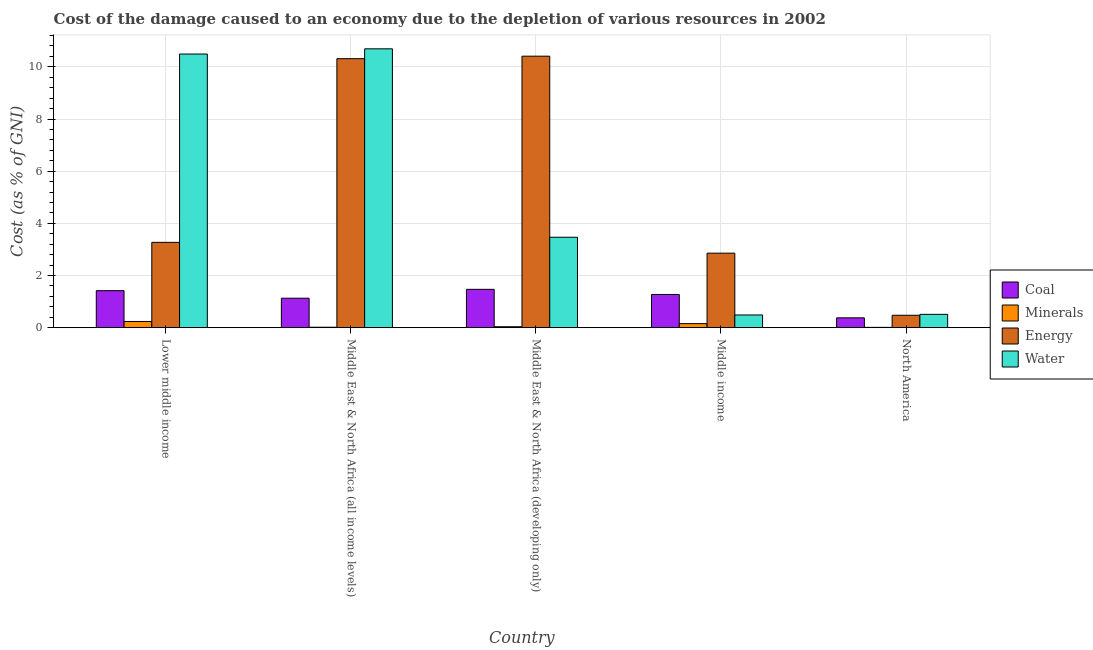How many groups of bars are there?
Your answer should be compact. 5. Are the number of bars per tick equal to the number of legend labels?
Your answer should be compact. Yes. How many bars are there on the 1st tick from the right?
Offer a terse response. 4. In how many cases, is the number of bars for a given country not equal to the number of legend labels?
Your response must be concise. 0. What is the cost of damage due to depletion of coal in North America?
Your response must be concise. 0.38. Across all countries, what is the maximum cost of damage due to depletion of water?
Give a very brief answer. 10.69. Across all countries, what is the minimum cost of damage due to depletion of coal?
Make the answer very short. 0.38. In which country was the cost of damage due to depletion of minerals maximum?
Offer a terse response. Lower middle income. What is the total cost of damage due to depletion of coal in the graph?
Ensure brevity in your answer.  5.67. What is the difference between the cost of damage due to depletion of minerals in Lower middle income and that in Middle East & North Africa (all income levels)?
Your answer should be very brief. 0.22. What is the difference between the cost of damage due to depletion of energy in Middle income and the cost of damage due to depletion of coal in Middle East & North Africa (all income levels)?
Your answer should be very brief. 1.73. What is the average cost of damage due to depletion of minerals per country?
Your response must be concise. 0.09. What is the difference between the cost of damage due to depletion of water and cost of damage due to depletion of minerals in Lower middle income?
Offer a terse response. 10.25. In how many countries, is the cost of damage due to depletion of water greater than 2.4 %?
Provide a succinct answer. 3. What is the ratio of the cost of damage due to depletion of energy in Lower middle income to that in Middle East & North Africa (developing only)?
Provide a short and direct response. 0.31. Is the cost of damage due to depletion of energy in Lower middle income less than that in Middle East & North Africa (all income levels)?
Ensure brevity in your answer.  Yes. What is the difference between the highest and the second highest cost of damage due to depletion of coal?
Your response must be concise. 0.05. What is the difference between the highest and the lowest cost of damage due to depletion of minerals?
Keep it short and to the point. 0.23. Is it the case that in every country, the sum of the cost of damage due to depletion of minerals and cost of damage due to depletion of coal is greater than the sum of cost of damage due to depletion of water and cost of damage due to depletion of energy?
Keep it short and to the point. Yes. What does the 2nd bar from the left in Middle income represents?
Offer a very short reply. Minerals. What does the 1st bar from the right in Lower middle income represents?
Provide a succinct answer. Water. Is it the case that in every country, the sum of the cost of damage due to depletion of coal and cost of damage due to depletion of minerals is greater than the cost of damage due to depletion of energy?
Keep it short and to the point. No. How many bars are there?
Provide a short and direct response. 20. How many countries are there in the graph?
Make the answer very short. 5. What is the difference between two consecutive major ticks on the Y-axis?
Your response must be concise. 2. Are the values on the major ticks of Y-axis written in scientific E-notation?
Your answer should be very brief. No. Does the graph contain grids?
Make the answer very short. Yes. How many legend labels are there?
Keep it short and to the point. 4. How are the legend labels stacked?
Your answer should be very brief. Vertical. What is the title of the graph?
Keep it short and to the point. Cost of the damage caused to an economy due to the depletion of various resources in 2002 . Does "Oil" appear as one of the legend labels in the graph?
Give a very brief answer. No. What is the label or title of the X-axis?
Ensure brevity in your answer.  Country. What is the label or title of the Y-axis?
Give a very brief answer. Cost (as % of GNI). What is the Cost (as % of GNI) of Coal in Lower middle income?
Keep it short and to the point. 1.42. What is the Cost (as % of GNI) in Minerals in Lower middle income?
Your response must be concise. 0.24. What is the Cost (as % of GNI) in Energy in Lower middle income?
Ensure brevity in your answer.  3.27. What is the Cost (as % of GNI) of Water in Lower middle income?
Your answer should be compact. 10.49. What is the Cost (as % of GNI) in Coal in Middle East & North Africa (all income levels)?
Your answer should be very brief. 1.13. What is the Cost (as % of GNI) of Minerals in Middle East & North Africa (all income levels)?
Your response must be concise. 0.02. What is the Cost (as % of GNI) of Energy in Middle East & North Africa (all income levels)?
Offer a terse response. 10.31. What is the Cost (as % of GNI) of Water in Middle East & North Africa (all income levels)?
Your answer should be very brief. 10.69. What is the Cost (as % of GNI) in Coal in Middle East & North Africa (developing only)?
Your answer should be very brief. 1.47. What is the Cost (as % of GNI) of Minerals in Middle East & North Africa (developing only)?
Your response must be concise. 0.04. What is the Cost (as % of GNI) in Energy in Middle East & North Africa (developing only)?
Make the answer very short. 10.41. What is the Cost (as % of GNI) in Water in Middle East & North Africa (developing only)?
Make the answer very short. 3.47. What is the Cost (as % of GNI) in Coal in Middle income?
Ensure brevity in your answer.  1.27. What is the Cost (as % of GNI) of Minerals in Middle income?
Provide a succinct answer. 0.16. What is the Cost (as % of GNI) in Energy in Middle income?
Make the answer very short. 2.86. What is the Cost (as % of GNI) of Water in Middle income?
Your answer should be very brief. 0.49. What is the Cost (as % of GNI) of Coal in North America?
Give a very brief answer. 0.38. What is the Cost (as % of GNI) of Minerals in North America?
Your answer should be very brief. 0.01. What is the Cost (as % of GNI) of Energy in North America?
Your answer should be very brief. 0.48. What is the Cost (as % of GNI) of Water in North America?
Your response must be concise. 0.51. Across all countries, what is the maximum Cost (as % of GNI) in Coal?
Make the answer very short. 1.47. Across all countries, what is the maximum Cost (as % of GNI) of Minerals?
Offer a very short reply. 0.24. Across all countries, what is the maximum Cost (as % of GNI) of Energy?
Offer a terse response. 10.41. Across all countries, what is the maximum Cost (as % of GNI) in Water?
Provide a short and direct response. 10.69. Across all countries, what is the minimum Cost (as % of GNI) in Coal?
Ensure brevity in your answer.  0.38. Across all countries, what is the minimum Cost (as % of GNI) in Minerals?
Offer a very short reply. 0.01. Across all countries, what is the minimum Cost (as % of GNI) of Energy?
Provide a succinct answer. 0.48. Across all countries, what is the minimum Cost (as % of GNI) of Water?
Make the answer very short. 0.49. What is the total Cost (as % of GNI) of Coal in the graph?
Ensure brevity in your answer.  5.67. What is the total Cost (as % of GNI) of Minerals in the graph?
Your answer should be compact. 0.46. What is the total Cost (as % of GNI) of Energy in the graph?
Ensure brevity in your answer.  27.33. What is the total Cost (as % of GNI) in Water in the graph?
Provide a succinct answer. 25.65. What is the difference between the Cost (as % of GNI) of Coal in Lower middle income and that in Middle East & North Africa (all income levels)?
Provide a short and direct response. 0.29. What is the difference between the Cost (as % of GNI) in Minerals in Lower middle income and that in Middle East & North Africa (all income levels)?
Offer a very short reply. 0.22. What is the difference between the Cost (as % of GNI) of Energy in Lower middle income and that in Middle East & North Africa (all income levels)?
Ensure brevity in your answer.  -7.04. What is the difference between the Cost (as % of GNI) in Water in Lower middle income and that in Middle East & North Africa (all income levels)?
Your answer should be very brief. -0.2. What is the difference between the Cost (as % of GNI) of Coal in Lower middle income and that in Middle East & North Africa (developing only)?
Ensure brevity in your answer.  -0.05. What is the difference between the Cost (as % of GNI) in Minerals in Lower middle income and that in Middle East & North Africa (developing only)?
Make the answer very short. 0.2. What is the difference between the Cost (as % of GNI) in Energy in Lower middle income and that in Middle East & North Africa (developing only)?
Your answer should be compact. -7.14. What is the difference between the Cost (as % of GNI) of Water in Lower middle income and that in Middle East & North Africa (developing only)?
Offer a very short reply. 7.02. What is the difference between the Cost (as % of GNI) in Coal in Lower middle income and that in Middle income?
Provide a short and direct response. 0.15. What is the difference between the Cost (as % of GNI) in Minerals in Lower middle income and that in Middle income?
Your answer should be very brief. 0.08. What is the difference between the Cost (as % of GNI) in Energy in Lower middle income and that in Middle income?
Make the answer very short. 0.41. What is the difference between the Cost (as % of GNI) of Water in Lower middle income and that in Middle income?
Your response must be concise. 10.01. What is the difference between the Cost (as % of GNI) in Coal in Lower middle income and that in North America?
Your answer should be compact. 1.04. What is the difference between the Cost (as % of GNI) in Minerals in Lower middle income and that in North America?
Provide a short and direct response. 0.23. What is the difference between the Cost (as % of GNI) in Energy in Lower middle income and that in North America?
Your answer should be very brief. 2.8. What is the difference between the Cost (as % of GNI) of Water in Lower middle income and that in North America?
Ensure brevity in your answer.  9.98. What is the difference between the Cost (as % of GNI) in Coal in Middle East & North Africa (all income levels) and that in Middle East & North Africa (developing only)?
Offer a very short reply. -0.34. What is the difference between the Cost (as % of GNI) in Minerals in Middle East & North Africa (all income levels) and that in Middle East & North Africa (developing only)?
Make the answer very short. -0.02. What is the difference between the Cost (as % of GNI) in Energy in Middle East & North Africa (all income levels) and that in Middle East & North Africa (developing only)?
Offer a very short reply. -0.1. What is the difference between the Cost (as % of GNI) of Water in Middle East & North Africa (all income levels) and that in Middle East & North Africa (developing only)?
Ensure brevity in your answer.  7.22. What is the difference between the Cost (as % of GNI) of Coal in Middle East & North Africa (all income levels) and that in Middle income?
Give a very brief answer. -0.14. What is the difference between the Cost (as % of GNI) in Minerals in Middle East & North Africa (all income levels) and that in Middle income?
Keep it short and to the point. -0.14. What is the difference between the Cost (as % of GNI) in Energy in Middle East & North Africa (all income levels) and that in Middle income?
Your answer should be very brief. 7.46. What is the difference between the Cost (as % of GNI) of Water in Middle East & North Africa (all income levels) and that in Middle income?
Make the answer very short. 10.2. What is the difference between the Cost (as % of GNI) in Coal in Middle East & North Africa (all income levels) and that in North America?
Make the answer very short. 0.75. What is the difference between the Cost (as % of GNI) of Minerals in Middle East & North Africa (all income levels) and that in North America?
Offer a very short reply. 0.01. What is the difference between the Cost (as % of GNI) in Energy in Middle East & North Africa (all income levels) and that in North America?
Keep it short and to the point. 9.84. What is the difference between the Cost (as % of GNI) in Water in Middle East & North Africa (all income levels) and that in North America?
Make the answer very short. 10.18. What is the difference between the Cost (as % of GNI) in Coal in Middle East & North Africa (developing only) and that in Middle income?
Your response must be concise. 0.2. What is the difference between the Cost (as % of GNI) in Minerals in Middle East & North Africa (developing only) and that in Middle income?
Offer a very short reply. -0.12. What is the difference between the Cost (as % of GNI) in Energy in Middle East & North Africa (developing only) and that in Middle income?
Ensure brevity in your answer.  7.55. What is the difference between the Cost (as % of GNI) in Water in Middle East & North Africa (developing only) and that in Middle income?
Offer a terse response. 2.98. What is the difference between the Cost (as % of GNI) of Coal in Middle East & North Africa (developing only) and that in North America?
Keep it short and to the point. 1.09. What is the difference between the Cost (as % of GNI) in Minerals in Middle East & North Africa (developing only) and that in North America?
Offer a very short reply. 0.02. What is the difference between the Cost (as % of GNI) in Energy in Middle East & North Africa (developing only) and that in North America?
Give a very brief answer. 9.93. What is the difference between the Cost (as % of GNI) of Water in Middle East & North Africa (developing only) and that in North America?
Keep it short and to the point. 2.96. What is the difference between the Cost (as % of GNI) in Coal in Middle income and that in North America?
Your answer should be compact. 0.9. What is the difference between the Cost (as % of GNI) in Minerals in Middle income and that in North America?
Your answer should be compact. 0.14. What is the difference between the Cost (as % of GNI) in Energy in Middle income and that in North America?
Ensure brevity in your answer.  2.38. What is the difference between the Cost (as % of GNI) in Water in Middle income and that in North America?
Provide a succinct answer. -0.02. What is the difference between the Cost (as % of GNI) of Coal in Lower middle income and the Cost (as % of GNI) of Minerals in Middle East & North Africa (all income levels)?
Ensure brevity in your answer.  1.4. What is the difference between the Cost (as % of GNI) of Coal in Lower middle income and the Cost (as % of GNI) of Energy in Middle East & North Africa (all income levels)?
Provide a succinct answer. -8.89. What is the difference between the Cost (as % of GNI) of Coal in Lower middle income and the Cost (as % of GNI) of Water in Middle East & North Africa (all income levels)?
Offer a terse response. -9.27. What is the difference between the Cost (as % of GNI) of Minerals in Lower middle income and the Cost (as % of GNI) of Energy in Middle East & North Africa (all income levels)?
Keep it short and to the point. -10.08. What is the difference between the Cost (as % of GNI) in Minerals in Lower middle income and the Cost (as % of GNI) in Water in Middle East & North Africa (all income levels)?
Give a very brief answer. -10.45. What is the difference between the Cost (as % of GNI) of Energy in Lower middle income and the Cost (as % of GNI) of Water in Middle East & North Africa (all income levels)?
Ensure brevity in your answer.  -7.42. What is the difference between the Cost (as % of GNI) of Coal in Lower middle income and the Cost (as % of GNI) of Minerals in Middle East & North Africa (developing only)?
Provide a short and direct response. 1.38. What is the difference between the Cost (as % of GNI) of Coal in Lower middle income and the Cost (as % of GNI) of Energy in Middle East & North Africa (developing only)?
Offer a terse response. -8.99. What is the difference between the Cost (as % of GNI) in Coal in Lower middle income and the Cost (as % of GNI) in Water in Middle East & North Africa (developing only)?
Give a very brief answer. -2.05. What is the difference between the Cost (as % of GNI) in Minerals in Lower middle income and the Cost (as % of GNI) in Energy in Middle East & North Africa (developing only)?
Give a very brief answer. -10.17. What is the difference between the Cost (as % of GNI) of Minerals in Lower middle income and the Cost (as % of GNI) of Water in Middle East & North Africa (developing only)?
Keep it short and to the point. -3.23. What is the difference between the Cost (as % of GNI) of Energy in Lower middle income and the Cost (as % of GNI) of Water in Middle East & North Africa (developing only)?
Give a very brief answer. -0.2. What is the difference between the Cost (as % of GNI) in Coal in Lower middle income and the Cost (as % of GNI) in Minerals in Middle income?
Offer a very short reply. 1.26. What is the difference between the Cost (as % of GNI) in Coal in Lower middle income and the Cost (as % of GNI) in Energy in Middle income?
Offer a terse response. -1.44. What is the difference between the Cost (as % of GNI) in Coal in Lower middle income and the Cost (as % of GNI) in Water in Middle income?
Make the answer very short. 0.93. What is the difference between the Cost (as % of GNI) in Minerals in Lower middle income and the Cost (as % of GNI) in Energy in Middle income?
Offer a very short reply. -2.62. What is the difference between the Cost (as % of GNI) of Minerals in Lower middle income and the Cost (as % of GNI) of Water in Middle income?
Make the answer very short. -0.25. What is the difference between the Cost (as % of GNI) of Energy in Lower middle income and the Cost (as % of GNI) of Water in Middle income?
Provide a short and direct response. 2.78. What is the difference between the Cost (as % of GNI) of Coal in Lower middle income and the Cost (as % of GNI) of Minerals in North America?
Offer a terse response. 1.41. What is the difference between the Cost (as % of GNI) in Coal in Lower middle income and the Cost (as % of GNI) in Energy in North America?
Your answer should be compact. 0.94. What is the difference between the Cost (as % of GNI) of Coal in Lower middle income and the Cost (as % of GNI) of Water in North America?
Your answer should be compact. 0.91. What is the difference between the Cost (as % of GNI) of Minerals in Lower middle income and the Cost (as % of GNI) of Energy in North America?
Provide a short and direct response. -0.24. What is the difference between the Cost (as % of GNI) in Minerals in Lower middle income and the Cost (as % of GNI) in Water in North America?
Provide a short and direct response. -0.27. What is the difference between the Cost (as % of GNI) of Energy in Lower middle income and the Cost (as % of GNI) of Water in North America?
Your response must be concise. 2.76. What is the difference between the Cost (as % of GNI) of Coal in Middle East & North Africa (all income levels) and the Cost (as % of GNI) of Minerals in Middle East & North Africa (developing only)?
Your response must be concise. 1.09. What is the difference between the Cost (as % of GNI) of Coal in Middle East & North Africa (all income levels) and the Cost (as % of GNI) of Energy in Middle East & North Africa (developing only)?
Your answer should be compact. -9.28. What is the difference between the Cost (as % of GNI) of Coal in Middle East & North Africa (all income levels) and the Cost (as % of GNI) of Water in Middle East & North Africa (developing only)?
Keep it short and to the point. -2.34. What is the difference between the Cost (as % of GNI) in Minerals in Middle East & North Africa (all income levels) and the Cost (as % of GNI) in Energy in Middle East & North Africa (developing only)?
Make the answer very short. -10.39. What is the difference between the Cost (as % of GNI) in Minerals in Middle East & North Africa (all income levels) and the Cost (as % of GNI) in Water in Middle East & North Africa (developing only)?
Provide a succinct answer. -3.45. What is the difference between the Cost (as % of GNI) in Energy in Middle East & North Africa (all income levels) and the Cost (as % of GNI) in Water in Middle East & North Africa (developing only)?
Ensure brevity in your answer.  6.85. What is the difference between the Cost (as % of GNI) of Coal in Middle East & North Africa (all income levels) and the Cost (as % of GNI) of Minerals in Middle income?
Offer a very short reply. 0.97. What is the difference between the Cost (as % of GNI) of Coal in Middle East & North Africa (all income levels) and the Cost (as % of GNI) of Energy in Middle income?
Make the answer very short. -1.73. What is the difference between the Cost (as % of GNI) in Coal in Middle East & North Africa (all income levels) and the Cost (as % of GNI) in Water in Middle income?
Offer a very short reply. 0.64. What is the difference between the Cost (as % of GNI) in Minerals in Middle East & North Africa (all income levels) and the Cost (as % of GNI) in Energy in Middle income?
Your answer should be compact. -2.84. What is the difference between the Cost (as % of GNI) in Minerals in Middle East & North Africa (all income levels) and the Cost (as % of GNI) in Water in Middle income?
Your answer should be very brief. -0.47. What is the difference between the Cost (as % of GNI) in Energy in Middle East & North Africa (all income levels) and the Cost (as % of GNI) in Water in Middle income?
Make the answer very short. 9.83. What is the difference between the Cost (as % of GNI) in Coal in Middle East & North Africa (all income levels) and the Cost (as % of GNI) in Minerals in North America?
Your answer should be compact. 1.12. What is the difference between the Cost (as % of GNI) of Coal in Middle East & North Africa (all income levels) and the Cost (as % of GNI) of Energy in North America?
Offer a terse response. 0.65. What is the difference between the Cost (as % of GNI) in Coal in Middle East & North Africa (all income levels) and the Cost (as % of GNI) in Water in North America?
Give a very brief answer. 0.62. What is the difference between the Cost (as % of GNI) in Minerals in Middle East & North Africa (all income levels) and the Cost (as % of GNI) in Energy in North America?
Offer a very short reply. -0.46. What is the difference between the Cost (as % of GNI) in Minerals in Middle East & North Africa (all income levels) and the Cost (as % of GNI) in Water in North America?
Provide a succinct answer. -0.49. What is the difference between the Cost (as % of GNI) of Energy in Middle East & North Africa (all income levels) and the Cost (as % of GNI) of Water in North America?
Keep it short and to the point. 9.8. What is the difference between the Cost (as % of GNI) of Coal in Middle East & North Africa (developing only) and the Cost (as % of GNI) of Minerals in Middle income?
Give a very brief answer. 1.31. What is the difference between the Cost (as % of GNI) of Coal in Middle East & North Africa (developing only) and the Cost (as % of GNI) of Energy in Middle income?
Your answer should be compact. -1.39. What is the difference between the Cost (as % of GNI) in Coal in Middle East & North Africa (developing only) and the Cost (as % of GNI) in Water in Middle income?
Ensure brevity in your answer.  0.98. What is the difference between the Cost (as % of GNI) in Minerals in Middle East & North Africa (developing only) and the Cost (as % of GNI) in Energy in Middle income?
Ensure brevity in your answer.  -2.82. What is the difference between the Cost (as % of GNI) in Minerals in Middle East & North Africa (developing only) and the Cost (as % of GNI) in Water in Middle income?
Keep it short and to the point. -0.45. What is the difference between the Cost (as % of GNI) of Energy in Middle East & North Africa (developing only) and the Cost (as % of GNI) of Water in Middle income?
Keep it short and to the point. 9.92. What is the difference between the Cost (as % of GNI) in Coal in Middle East & North Africa (developing only) and the Cost (as % of GNI) in Minerals in North America?
Ensure brevity in your answer.  1.46. What is the difference between the Cost (as % of GNI) of Coal in Middle East & North Africa (developing only) and the Cost (as % of GNI) of Energy in North America?
Your answer should be very brief. 0.99. What is the difference between the Cost (as % of GNI) of Coal in Middle East & North Africa (developing only) and the Cost (as % of GNI) of Water in North America?
Your response must be concise. 0.96. What is the difference between the Cost (as % of GNI) of Minerals in Middle East & North Africa (developing only) and the Cost (as % of GNI) of Energy in North America?
Your response must be concise. -0.44. What is the difference between the Cost (as % of GNI) in Minerals in Middle East & North Africa (developing only) and the Cost (as % of GNI) in Water in North America?
Your response must be concise. -0.47. What is the difference between the Cost (as % of GNI) of Energy in Middle East & North Africa (developing only) and the Cost (as % of GNI) of Water in North America?
Offer a very short reply. 9.9. What is the difference between the Cost (as % of GNI) of Coal in Middle income and the Cost (as % of GNI) of Minerals in North America?
Keep it short and to the point. 1.26. What is the difference between the Cost (as % of GNI) of Coal in Middle income and the Cost (as % of GNI) of Energy in North America?
Ensure brevity in your answer.  0.8. What is the difference between the Cost (as % of GNI) of Coal in Middle income and the Cost (as % of GNI) of Water in North America?
Your answer should be compact. 0.76. What is the difference between the Cost (as % of GNI) of Minerals in Middle income and the Cost (as % of GNI) of Energy in North America?
Your answer should be very brief. -0.32. What is the difference between the Cost (as % of GNI) of Minerals in Middle income and the Cost (as % of GNI) of Water in North America?
Give a very brief answer. -0.35. What is the difference between the Cost (as % of GNI) of Energy in Middle income and the Cost (as % of GNI) of Water in North America?
Provide a short and direct response. 2.35. What is the average Cost (as % of GNI) in Coal per country?
Provide a short and direct response. 1.13. What is the average Cost (as % of GNI) of Minerals per country?
Offer a very short reply. 0.09. What is the average Cost (as % of GNI) in Energy per country?
Your answer should be very brief. 5.47. What is the average Cost (as % of GNI) of Water per country?
Give a very brief answer. 5.13. What is the difference between the Cost (as % of GNI) of Coal and Cost (as % of GNI) of Minerals in Lower middle income?
Give a very brief answer. 1.18. What is the difference between the Cost (as % of GNI) in Coal and Cost (as % of GNI) in Energy in Lower middle income?
Your response must be concise. -1.85. What is the difference between the Cost (as % of GNI) of Coal and Cost (as % of GNI) of Water in Lower middle income?
Make the answer very short. -9.07. What is the difference between the Cost (as % of GNI) of Minerals and Cost (as % of GNI) of Energy in Lower middle income?
Ensure brevity in your answer.  -3.03. What is the difference between the Cost (as % of GNI) in Minerals and Cost (as % of GNI) in Water in Lower middle income?
Provide a short and direct response. -10.25. What is the difference between the Cost (as % of GNI) of Energy and Cost (as % of GNI) of Water in Lower middle income?
Provide a short and direct response. -7.22. What is the difference between the Cost (as % of GNI) in Coal and Cost (as % of GNI) in Minerals in Middle East & North Africa (all income levels)?
Offer a very short reply. 1.11. What is the difference between the Cost (as % of GNI) in Coal and Cost (as % of GNI) in Energy in Middle East & North Africa (all income levels)?
Offer a very short reply. -9.18. What is the difference between the Cost (as % of GNI) in Coal and Cost (as % of GNI) in Water in Middle East & North Africa (all income levels)?
Keep it short and to the point. -9.56. What is the difference between the Cost (as % of GNI) of Minerals and Cost (as % of GNI) of Energy in Middle East & North Africa (all income levels)?
Make the answer very short. -10.3. What is the difference between the Cost (as % of GNI) in Minerals and Cost (as % of GNI) in Water in Middle East & North Africa (all income levels)?
Your answer should be compact. -10.67. What is the difference between the Cost (as % of GNI) in Energy and Cost (as % of GNI) in Water in Middle East & North Africa (all income levels)?
Your response must be concise. -0.38. What is the difference between the Cost (as % of GNI) of Coal and Cost (as % of GNI) of Minerals in Middle East & North Africa (developing only)?
Your response must be concise. 1.43. What is the difference between the Cost (as % of GNI) of Coal and Cost (as % of GNI) of Energy in Middle East & North Africa (developing only)?
Your answer should be compact. -8.94. What is the difference between the Cost (as % of GNI) in Coal and Cost (as % of GNI) in Water in Middle East & North Africa (developing only)?
Make the answer very short. -2. What is the difference between the Cost (as % of GNI) in Minerals and Cost (as % of GNI) in Energy in Middle East & North Africa (developing only)?
Your response must be concise. -10.37. What is the difference between the Cost (as % of GNI) of Minerals and Cost (as % of GNI) of Water in Middle East & North Africa (developing only)?
Give a very brief answer. -3.43. What is the difference between the Cost (as % of GNI) of Energy and Cost (as % of GNI) of Water in Middle East & North Africa (developing only)?
Offer a terse response. 6.94. What is the difference between the Cost (as % of GNI) in Coal and Cost (as % of GNI) in Minerals in Middle income?
Provide a short and direct response. 1.12. What is the difference between the Cost (as % of GNI) of Coal and Cost (as % of GNI) of Energy in Middle income?
Provide a succinct answer. -1.58. What is the difference between the Cost (as % of GNI) of Coal and Cost (as % of GNI) of Water in Middle income?
Provide a short and direct response. 0.79. What is the difference between the Cost (as % of GNI) in Minerals and Cost (as % of GNI) in Energy in Middle income?
Give a very brief answer. -2.7. What is the difference between the Cost (as % of GNI) of Minerals and Cost (as % of GNI) of Water in Middle income?
Provide a succinct answer. -0.33. What is the difference between the Cost (as % of GNI) of Energy and Cost (as % of GNI) of Water in Middle income?
Keep it short and to the point. 2.37. What is the difference between the Cost (as % of GNI) of Coal and Cost (as % of GNI) of Minerals in North America?
Offer a terse response. 0.37. What is the difference between the Cost (as % of GNI) in Coal and Cost (as % of GNI) in Energy in North America?
Your response must be concise. -0.1. What is the difference between the Cost (as % of GNI) of Coal and Cost (as % of GNI) of Water in North America?
Give a very brief answer. -0.13. What is the difference between the Cost (as % of GNI) of Minerals and Cost (as % of GNI) of Energy in North America?
Ensure brevity in your answer.  -0.46. What is the difference between the Cost (as % of GNI) of Minerals and Cost (as % of GNI) of Water in North America?
Keep it short and to the point. -0.5. What is the difference between the Cost (as % of GNI) of Energy and Cost (as % of GNI) of Water in North America?
Provide a short and direct response. -0.03. What is the ratio of the Cost (as % of GNI) in Coal in Lower middle income to that in Middle East & North Africa (all income levels)?
Give a very brief answer. 1.26. What is the ratio of the Cost (as % of GNI) of Minerals in Lower middle income to that in Middle East & North Africa (all income levels)?
Ensure brevity in your answer.  13.98. What is the ratio of the Cost (as % of GNI) of Energy in Lower middle income to that in Middle East & North Africa (all income levels)?
Provide a short and direct response. 0.32. What is the ratio of the Cost (as % of GNI) in Water in Lower middle income to that in Middle East & North Africa (all income levels)?
Offer a terse response. 0.98. What is the ratio of the Cost (as % of GNI) of Coal in Lower middle income to that in Middle East & North Africa (developing only)?
Keep it short and to the point. 0.97. What is the ratio of the Cost (as % of GNI) in Minerals in Lower middle income to that in Middle East & North Africa (developing only)?
Your answer should be very brief. 6.6. What is the ratio of the Cost (as % of GNI) in Energy in Lower middle income to that in Middle East & North Africa (developing only)?
Make the answer very short. 0.31. What is the ratio of the Cost (as % of GNI) of Water in Lower middle income to that in Middle East & North Africa (developing only)?
Your answer should be very brief. 3.03. What is the ratio of the Cost (as % of GNI) in Coal in Lower middle income to that in Middle income?
Provide a short and direct response. 1.11. What is the ratio of the Cost (as % of GNI) of Minerals in Lower middle income to that in Middle income?
Give a very brief answer. 1.53. What is the ratio of the Cost (as % of GNI) in Energy in Lower middle income to that in Middle income?
Ensure brevity in your answer.  1.15. What is the ratio of the Cost (as % of GNI) of Water in Lower middle income to that in Middle income?
Make the answer very short. 21.55. What is the ratio of the Cost (as % of GNI) in Coal in Lower middle income to that in North America?
Keep it short and to the point. 3.76. What is the ratio of the Cost (as % of GNI) of Minerals in Lower middle income to that in North America?
Keep it short and to the point. 21.36. What is the ratio of the Cost (as % of GNI) of Energy in Lower middle income to that in North America?
Offer a terse response. 6.88. What is the ratio of the Cost (as % of GNI) of Water in Lower middle income to that in North America?
Make the answer very short. 20.56. What is the ratio of the Cost (as % of GNI) in Coal in Middle East & North Africa (all income levels) to that in Middle East & North Africa (developing only)?
Your answer should be very brief. 0.77. What is the ratio of the Cost (as % of GNI) in Minerals in Middle East & North Africa (all income levels) to that in Middle East & North Africa (developing only)?
Ensure brevity in your answer.  0.47. What is the ratio of the Cost (as % of GNI) in Water in Middle East & North Africa (all income levels) to that in Middle East & North Africa (developing only)?
Ensure brevity in your answer.  3.08. What is the ratio of the Cost (as % of GNI) of Coal in Middle East & North Africa (all income levels) to that in Middle income?
Provide a succinct answer. 0.89. What is the ratio of the Cost (as % of GNI) of Minerals in Middle East & North Africa (all income levels) to that in Middle income?
Your answer should be compact. 0.11. What is the ratio of the Cost (as % of GNI) of Energy in Middle East & North Africa (all income levels) to that in Middle income?
Ensure brevity in your answer.  3.61. What is the ratio of the Cost (as % of GNI) in Water in Middle East & North Africa (all income levels) to that in Middle income?
Make the answer very short. 21.96. What is the ratio of the Cost (as % of GNI) in Coal in Middle East & North Africa (all income levels) to that in North America?
Provide a short and direct response. 2.99. What is the ratio of the Cost (as % of GNI) in Minerals in Middle East & North Africa (all income levels) to that in North America?
Your response must be concise. 1.53. What is the ratio of the Cost (as % of GNI) of Energy in Middle East & North Africa (all income levels) to that in North America?
Your response must be concise. 21.68. What is the ratio of the Cost (as % of GNI) of Water in Middle East & North Africa (all income levels) to that in North America?
Provide a succinct answer. 20.95. What is the ratio of the Cost (as % of GNI) in Coal in Middle East & North Africa (developing only) to that in Middle income?
Ensure brevity in your answer.  1.16. What is the ratio of the Cost (as % of GNI) of Minerals in Middle East & North Africa (developing only) to that in Middle income?
Your answer should be compact. 0.23. What is the ratio of the Cost (as % of GNI) in Energy in Middle East & North Africa (developing only) to that in Middle income?
Provide a succinct answer. 3.64. What is the ratio of the Cost (as % of GNI) of Water in Middle East & North Africa (developing only) to that in Middle income?
Give a very brief answer. 7.12. What is the ratio of the Cost (as % of GNI) of Coal in Middle East & North Africa (developing only) to that in North America?
Your answer should be compact. 3.89. What is the ratio of the Cost (as % of GNI) of Minerals in Middle East & North Africa (developing only) to that in North America?
Your response must be concise. 3.23. What is the ratio of the Cost (as % of GNI) in Energy in Middle East & North Africa (developing only) to that in North America?
Ensure brevity in your answer.  21.88. What is the ratio of the Cost (as % of GNI) of Water in Middle East & North Africa (developing only) to that in North America?
Provide a succinct answer. 6.79. What is the ratio of the Cost (as % of GNI) in Coal in Middle income to that in North America?
Provide a short and direct response. 3.37. What is the ratio of the Cost (as % of GNI) in Minerals in Middle income to that in North America?
Offer a very short reply. 13.98. What is the ratio of the Cost (as % of GNI) of Energy in Middle income to that in North America?
Keep it short and to the point. 6. What is the ratio of the Cost (as % of GNI) in Water in Middle income to that in North America?
Offer a very short reply. 0.95. What is the difference between the highest and the second highest Cost (as % of GNI) of Coal?
Your response must be concise. 0.05. What is the difference between the highest and the second highest Cost (as % of GNI) of Minerals?
Your response must be concise. 0.08. What is the difference between the highest and the second highest Cost (as % of GNI) of Energy?
Keep it short and to the point. 0.1. What is the difference between the highest and the second highest Cost (as % of GNI) in Water?
Provide a succinct answer. 0.2. What is the difference between the highest and the lowest Cost (as % of GNI) in Coal?
Your answer should be very brief. 1.09. What is the difference between the highest and the lowest Cost (as % of GNI) of Minerals?
Make the answer very short. 0.23. What is the difference between the highest and the lowest Cost (as % of GNI) of Energy?
Your answer should be very brief. 9.93. What is the difference between the highest and the lowest Cost (as % of GNI) of Water?
Provide a short and direct response. 10.2. 